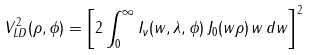Convert formula to latex. <formula><loc_0><loc_0><loc_500><loc_500>V ^ { 2 } _ { L D } ( \rho , \phi ) = \left [ 2 \int ^ { \infty } _ { 0 } I _ { \nu } ( w , \lambda , \phi ) \, J _ { 0 } ( w \rho ) \, w \, d w \right ] ^ { 2 }</formula> 